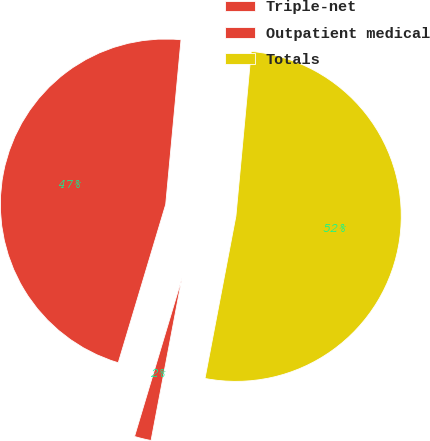<chart> <loc_0><loc_0><loc_500><loc_500><pie_chart><fcel>Triple-net<fcel>Outpatient medical<fcel>Totals<nl><fcel>46.84%<fcel>1.64%<fcel>51.52%<nl></chart> 